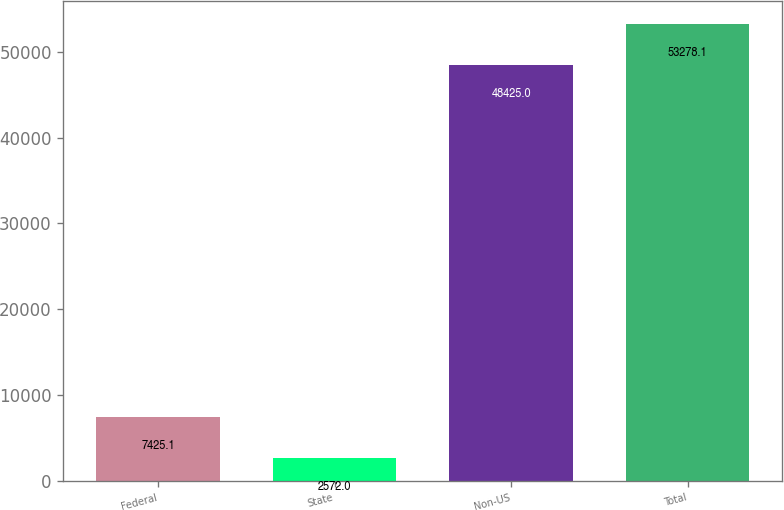Convert chart. <chart><loc_0><loc_0><loc_500><loc_500><bar_chart><fcel>Federal<fcel>State<fcel>Non-US<fcel>Total<nl><fcel>7425.1<fcel>2572<fcel>48425<fcel>53278.1<nl></chart> 